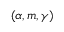Convert formula to latex. <formula><loc_0><loc_0><loc_500><loc_500>( \alpha , m , \gamma )</formula> 